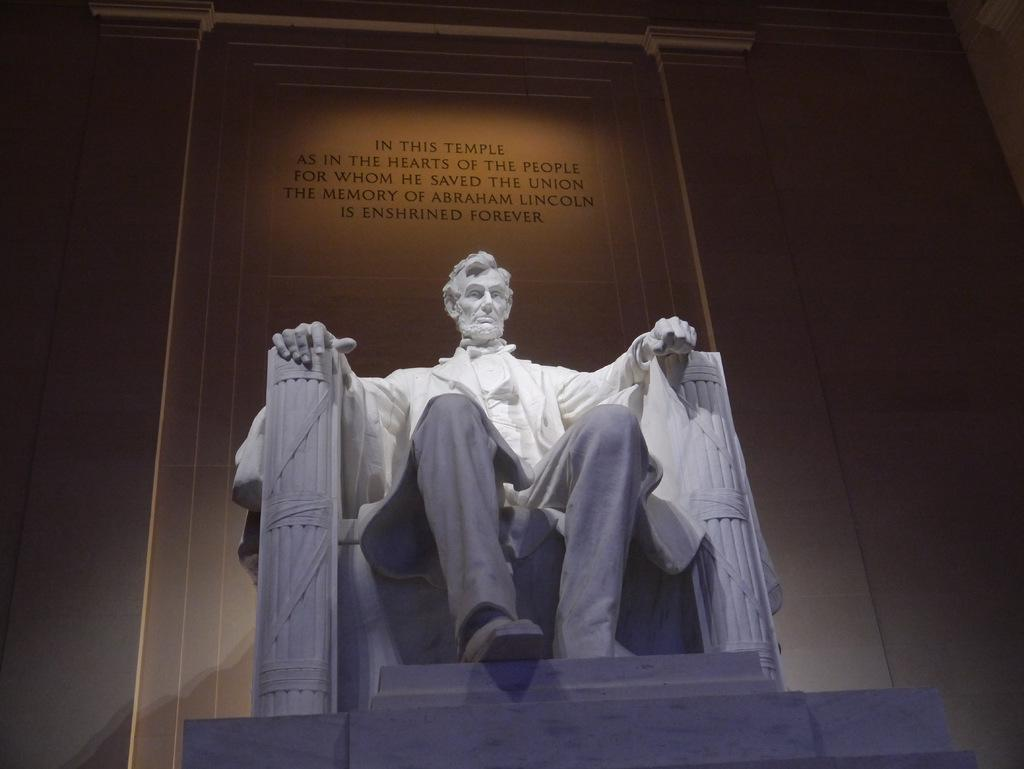What is the main subject of the image? There is a statue of a man in the image. What can be seen in the background of the image? There is a wall in the background of the image. What is written or depicted on the wall? There is text visible on the wall. How many fans are attached to the statue in the image? There are no fans present in the image; it features a statue of a man and a wall with text. 